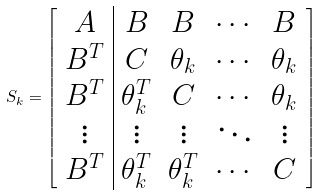Convert formula to latex. <formula><loc_0><loc_0><loc_500><loc_500>S _ { k } = \left [ \begin{array} { c | c c c c } A & B & B & \cdots & B \\ B ^ { T } & C & \theta _ { k } & \cdots & \theta _ { k } \\ B ^ { T } & \theta _ { k } ^ { T } & C & \cdots & \theta _ { k } \\ \vdots & \vdots & \vdots & \ddots & \vdots \\ B ^ { T } & \theta _ { k } ^ { T } & \theta _ { k } ^ { T } & \cdots & C \end{array} \right ]</formula> 